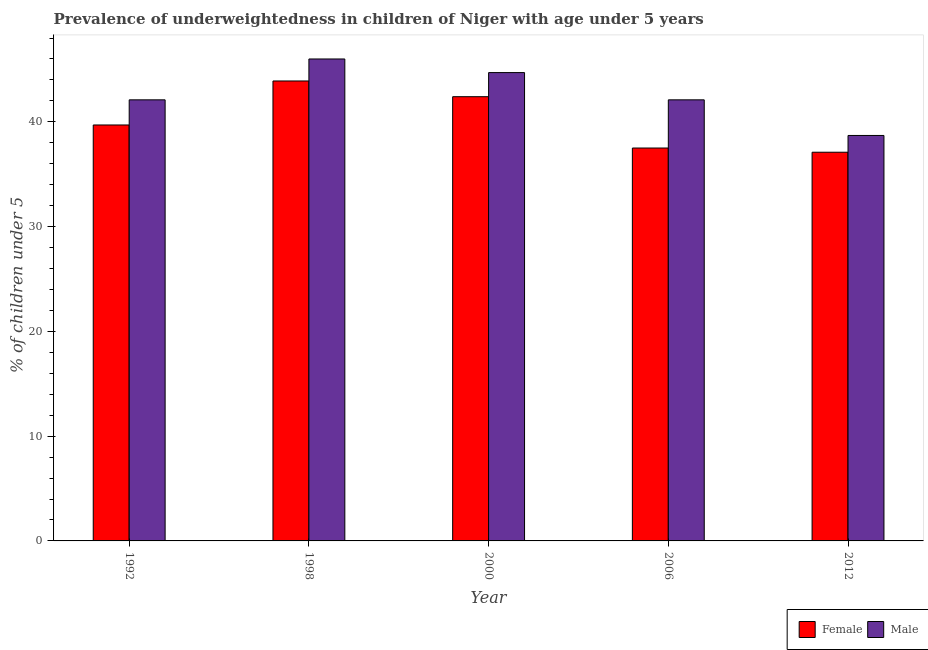Are the number of bars per tick equal to the number of legend labels?
Keep it short and to the point. Yes. Are the number of bars on each tick of the X-axis equal?
Provide a short and direct response. Yes. How many bars are there on the 5th tick from the left?
Your answer should be very brief. 2. How many bars are there on the 4th tick from the right?
Offer a terse response. 2. In how many cases, is the number of bars for a given year not equal to the number of legend labels?
Ensure brevity in your answer.  0. What is the percentage of underweighted male children in 1992?
Provide a succinct answer. 42.1. Across all years, what is the maximum percentage of underweighted female children?
Provide a short and direct response. 43.9. Across all years, what is the minimum percentage of underweighted female children?
Your answer should be very brief. 37.1. In which year was the percentage of underweighted female children minimum?
Provide a short and direct response. 2012. What is the total percentage of underweighted female children in the graph?
Ensure brevity in your answer.  200.6. What is the difference between the percentage of underweighted male children in 2006 and the percentage of underweighted female children in 2000?
Your response must be concise. -2.6. What is the average percentage of underweighted female children per year?
Offer a terse response. 40.12. In the year 2006, what is the difference between the percentage of underweighted female children and percentage of underweighted male children?
Offer a very short reply. 0. What is the ratio of the percentage of underweighted female children in 2000 to that in 2012?
Keep it short and to the point. 1.14. Is the difference between the percentage of underweighted male children in 2006 and 2012 greater than the difference between the percentage of underweighted female children in 2006 and 2012?
Your answer should be compact. No. What is the difference between the highest and the second highest percentage of underweighted male children?
Offer a very short reply. 1.3. What is the difference between the highest and the lowest percentage of underweighted male children?
Your answer should be very brief. 7.3. In how many years, is the percentage of underweighted female children greater than the average percentage of underweighted female children taken over all years?
Give a very brief answer. 2. What does the 1st bar from the left in 2006 represents?
Your answer should be very brief. Female. What does the 2nd bar from the right in 1998 represents?
Provide a short and direct response. Female. How many bars are there?
Give a very brief answer. 10. Does the graph contain grids?
Provide a short and direct response. No. How many legend labels are there?
Provide a short and direct response. 2. How are the legend labels stacked?
Provide a short and direct response. Horizontal. What is the title of the graph?
Keep it short and to the point. Prevalence of underweightedness in children of Niger with age under 5 years. What is the label or title of the Y-axis?
Make the answer very short.  % of children under 5. What is the  % of children under 5 of Female in 1992?
Give a very brief answer. 39.7. What is the  % of children under 5 in Male in 1992?
Make the answer very short. 42.1. What is the  % of children under 5 in Female in 1998?
Make the answer very short. 43.9. What is the  % of children under 5 in Male in 1998?
Your answer should be very brief. 46. What is the  % of children under 5 of Female in 2000?
Make the answer very short. 42.4. What is the  % of children under 5 of Male in 2000?
Provide a succinct answer. 44.7. What is the  % of children under 5 in Female in 2006?
Provide a succinct answer. 37.5. What is the  % of children under 5 of Male in 2006?
Keep it short and to the point. 42.1. What is the  % of children under 5 of Female in 2012?
Your response must be concise. 37.1. What is the  % of children under 5 of Male in 2012?
Offer a terse response. 38.7. Across all years, what is the maximum  % of children under 5 in Female?
Offer a very short reply. 43.9. Across all years, what is the minimum  % of children under 5 in Female?
Provide a succinct answer. 37.1. Across all years, what is the minimum  % of children under 5 of Male?
Make the answer very short. 38.7. What is the total  % of children under 5 in Female in the graph?
Your answer should be compact. 200.6. What is the total  % of children under 5 in Male in the graph?
Keep it short and to the point. 213.6. What is the difference between the  % of children under 5 of Male in 1992 and that in 2000?
Make the answer very short. -2.6. What is the difference between the  % of children under 5 in Female in 1992 and that in 2006?
Your answer should be compact. 2.2. What is the difference between the  % of children under 5 in Male in 1992 and that in 2006?
Ensure brevity in your answer.  0. What is the difference between the  % of children under 5 of Female in 1992 and that in 2012?
Make the answer very short. 2.6. What is the difference between the  % of children under 5 in Female in 1998 and that in 2000?
Your response must be concise. 1.5. What is the difference between the  % of children under 5 of Male in 1998 and that in 2006?
Make the answer very short. 3.9. What is the difference between the  % of children under 5 in Female in 1998 and that in 2012?
Give a very brief answer. 6.8. What is the difference between the  % of children under 5 of Male in 1998 and that in 2012?
Make the answer very short. 7.3. What is the difference between the  % of children under 5 in Male in 2000 and that in 2006?
Your response must be concise. 2.6. What is the difference between the  % of children under 5 of Female in 2006 and that in 2012?
Keep it short and to the point. 0.4. What is the difference between the  % of children under 5 of Male in 2006 and that in 2012?
Keep it short and to the point. 3.4. What is the difference between the  % of children under 5 in Female in 1998 and the  % of children under 5 in Male in 2000?
Your answer should be very brief. -0.8. What is the difference between the  % of children under 5 of Female in 1998 and the  % of children under 5 of Male in 2012?
Your answer should be very brief. 5.2. What is the difference between the  % of children under 5 in Female in 2000 and the  % of children under 5 in Male in 2006?
Give a very brief answer. 0.3. What is the difference between the  % of children under 5 in Female in 2000 and the  % of children under 5 in Male in 2012?
Keep it short and to the point. 3.7. What is the difference between the  % of children under 5 in Female in 2006 and the  % of children under 5 in Male in 2012?
Give a very brief answer. -1.2. What is the average  % of children under 5 in Female per year?
Provide a short and direct response. 40.12. What is the average  % of children under 5 in Male per year?
Keep it short and to the point. 42.72. In the year 2000, what is the difference between the  % of children under 5 in Female and  % of children under 5 in Male?
Your answer should be compact. -2.3. What is the ratio of the  % of children under 5 of Female in 1992 to that in 1998?
Your response must be concise. 0.9. What is the ratio of the  % of children under 5 in Male in 1992 to that in 1998?
Offer a very short reply. 0.92. What is the ratio of the  % of children under 5 of Female in 1992 to that in 2000?
Your answer should be compact. 0.94. What is the ratio of the  % of children under 5 in Male in 1992 to that in 2000?
Your answer should be very brief. 0.94. What is the ratio of the  % of children under 5 of Female in 1992 to that in 2006?
Your answer should be very brief. 1.06. What is the ratio of the  % of children under 5 in Female in 1992 to that in 2012?
Keep it short and to the point. 1.07. What is the ratio of the  % of children under 5 in Male in 1992 to that in 2012?
Ensure brevity in your answer.  1.09. What is the ratio of the  % of children under 5 in Female in 1998 to that in 2000?
Keep it short and to the point. 1.04. What is the ratio of the  % of children under 5 in Male in 1998 to that in 2000?
Your answer should be compact. 1.03. What is the ratio of the  % of children under 5 of Female in 1998 to that in 2006?
Your answer should be very brief. 1.17. What is the ratio of the  % of children under 5 in Male in 1998 to that in 2006?
Offer a very short reply. 1.09. What is the ratio of the  % of children under 5 of Female in 1998 to that in 2012?
Offer a terse response. 1.18. What is the ratio of the  % of children under 5 in Male in 1998 to that in 2012?
Your answer should be compact. 1.19. What is the ratio of the  % of children under 5 in Female in 2000 to that in 2006?
Offer a very short reply. 1.13. What is the ratio of the  % of children under 5 in Male in 2000 to that in 2006?
Ensure brevity in your answer.  1.06. What is the ratio of the  % of children under 5 of Male in 2000 to that in 2012?
Provide a short and direct response. 1.16. What is the ratio of the  % of children under 5 of Female in 2006 to that in 2012?
Ensure brevity in your answer.  1.01. What is the ratio of the  % of children under 5 of Male in 2006 to that in 2012?
Give a very brief answer. 1.09. What is the difference between the highest and the second highest  % of children under 5 of Female?
Your answer should be compact. 1.5. What is the difference between the highest and the second highest  % of children under 5 in Male?
Offer a terse response. 1.3. What is the difference between the highest and the lowest  % of children under 5 of Male?
Your answer should be compact. 7.3. 